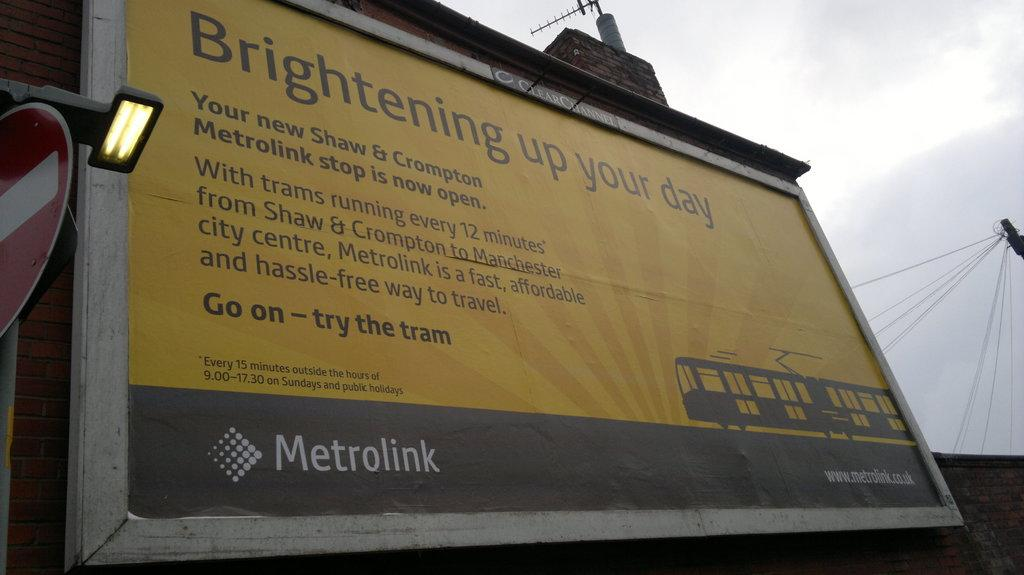<image>
Present a compact description of the photo's key features. Whole billboard for Metrolink that wants brighten your day 